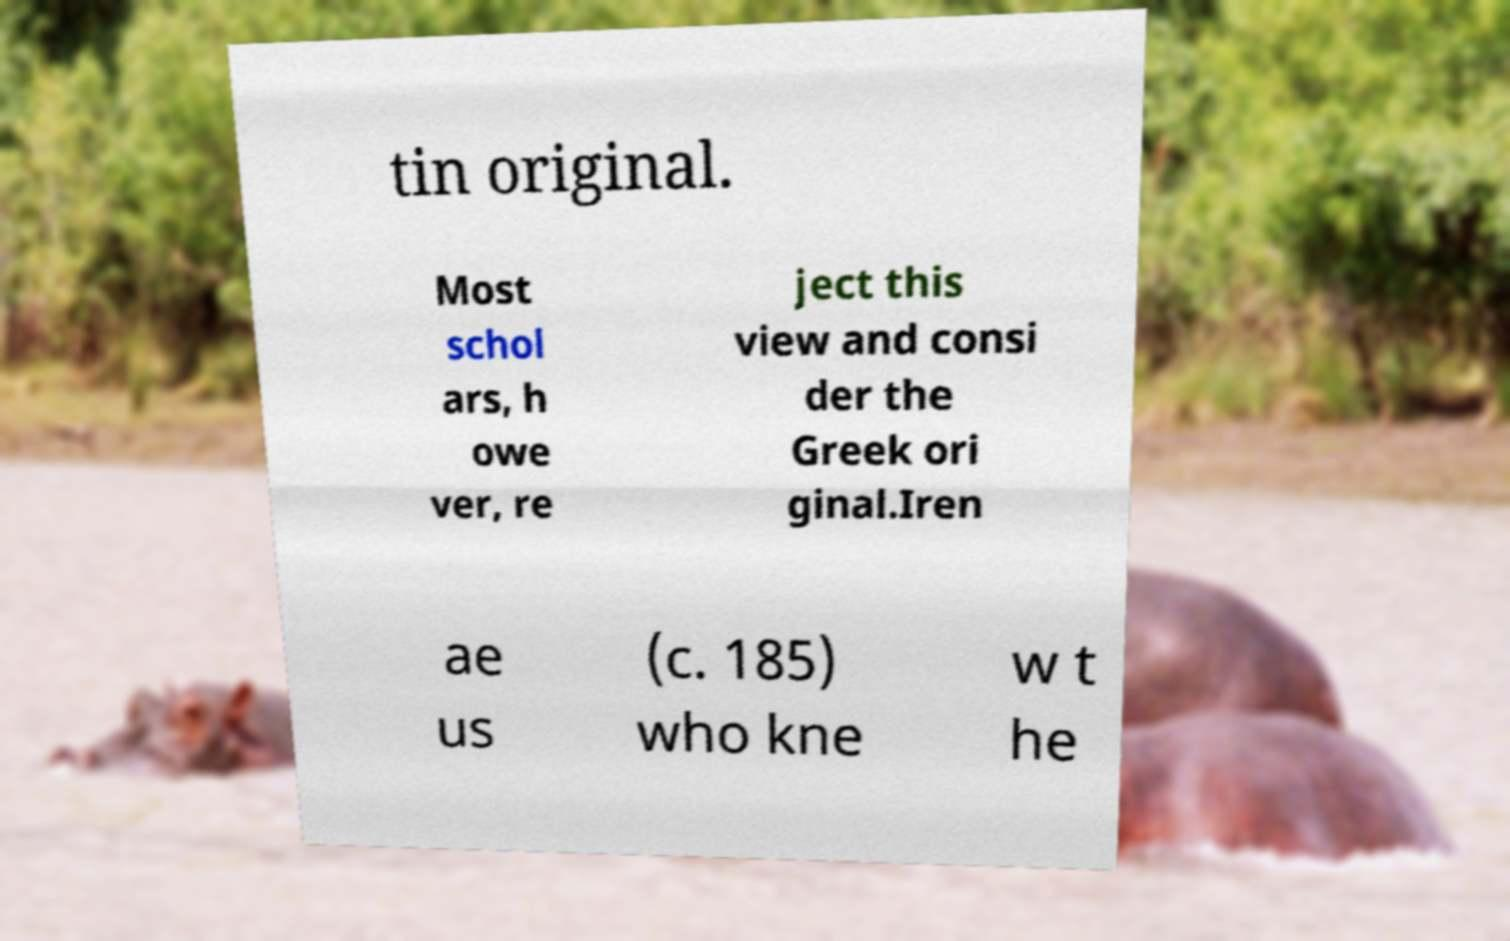There's text embedded in this image that I need extracted. Can you transcribe it verbatim? tin original. Most schol ars, h owe ver, re ject this view and consi der the Greek ori ginal.Iren ae us (c. 185) who kne w t he 